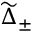Convert formula to latex. <formula><loc_0><loc_0><loc_500><loc_500>\widetilde { \Delta } _ { \pm }</formula> 